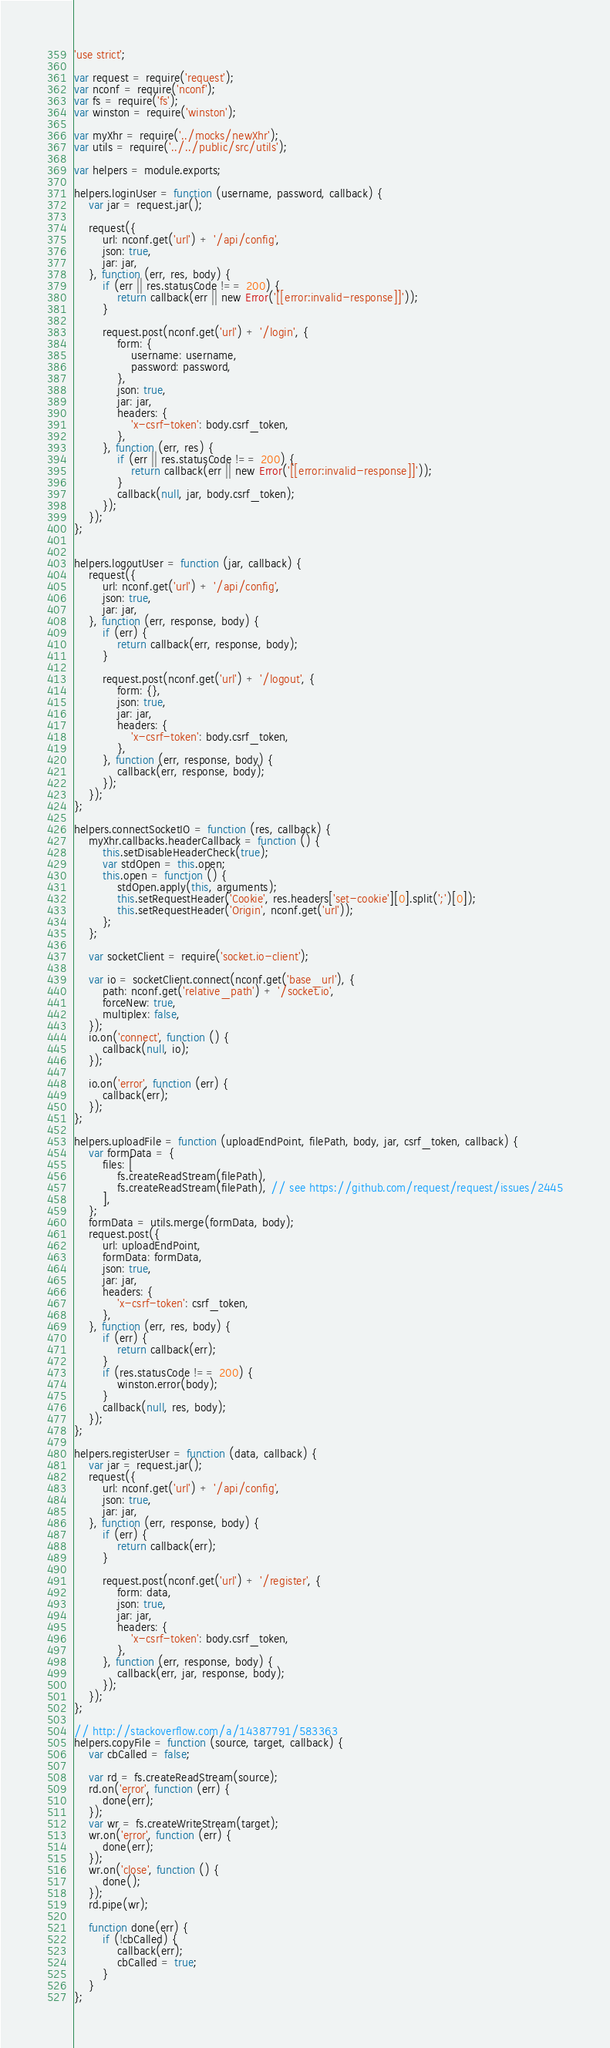<code> <loc_0><loc_0><loc_500><loc_500><_JavaScript_>'use strict';

var request = require('request');
var nconf = require('nconf');
var fs = require('fs');
var winston = require('winston');

var myXhr = require('../mocks/newXhr');
var utils = require('../../public/src/utils');

var helpers = module.exports;

helpers.loginUser = function (username, password, callback) {
	var jar = request.jar();

	request({
		url: nconf.get('url') + '/api/config',
		json: true,
		jar: jar,
	}, function (err, res, body) {
		if (err || res.statusCode !== 200) {
			return callback(err || new Error('[[error:invalid-response]]'));
		}

		request.post(nconf.get('url') + '/login', {
			form: {
				username: username,
				password: password,
			},
			json: true,
			jar: jar,
			headers: {
				'x-csrf-token': body.csrf_token,
			},
		}, function (err, res) {
			if (err || res.statusCode !== 200) {
				return callback(err || new Error('[[error:invalid-response]]'));
			}
			callback(null, jar, body.csrf_token);
		});
	});
};


helpers.logoutUser = function (jar, callback) {
	request({
		url: nconf.get('url') + '/api/config',
		json: true,
		jar: jar,
	}, function (err, response, body) {
		if (err) {
			return callback(err, response, body);
		}

		request.post(nconf.get('url') + '/logout', {
			form: {},
			json: true,
			jar: jar,
			headers: {
				'x-csrf-token': body.csrf_token,
			},
		}, function (err, response, body) {
			callback(err, response, body);
		});
	});
};

helpers.connectSocketIO = function (res, callback) {
	myXhr.callbacks.headerCallback = function () {
		this.setDisableHeaderCheck(true);
		var stdOpen = this.open;
		this.open = function () {
			stdOpen.apply(this, arguments);
			this.setRequestHeader('Cookie', res.headers['set-cookie'][0].split(';')[0]);
			this.setRequestHeader('Origin', nconf.get('url'));
		};
	};

	var socketClient = require('socket.io-client');

	var io = socketClient.connect(nconf.get('base_url'), {
		path: nconf.get('relative_path') + '/socket.io',
		forceNew: true,
		multiplex: false,
	});
	io.on('connect', function () {
		callback(null, io);
	});

	io.on('error', function (err) {
		callback(err);
	});
};

helpers.uploadFile = function (uploadEndPoint, filePath, body, jar, csrf_token, callback) {
	var formData = {
		files: [
			fs.createReadStream(filePath),
			fs.createReadStream(filePath), // see https://github.com/request/request/issues/2445
		],
	};
	formData = utils.merge(formData, body);
	request.post({
		url: uploadEndPoint,
		formData: formData,
		json: true,
		jar: jar,
		headers: {
			'x-csrf-token': csrf_token,
		},
	}, function (err, res, body) {
		if (err) {
			return callback(err);
		}
		if (res.statusCode !== 200) {
			winston.error(body);
		}
		callback(null, res, body);
	});
};

helpers.registerUser = function (data, callback) {
	var jar = request.jar();
	request({
		url: nconf.get('url') + '/api/config',
		json: true,
		jar: jar,
	}, function (err, response, body) {
		if (err) {
			return callback(err);
		}

		request.post(nconf.get('url') + '/register', {
			form: data,
			json: true,
			jar: jar,
			headers: {
				'x-csrf-token': body.csrf_token,
			},
		}, function (err, response, body) {
			callback(err, jar, response, body);
		});
	});
};

// http://stackoverflow.com/a/14387791/583363
helpers.copyFile = function (source, target, callback) {
	var cbCalled = false;

	var rd = fs.createReadStream(source);
	rd.on('error', function (err) {
		done(err);
	});
	var wr = fs.createWriteStream(target);
	wr.on('error', function (err) {
		done(err);
	});
	wr.on('close', function () {
		done();
	});
	rd.pipe(wr);

	function done(err) {
		if (!cbCalled) {
			callback(err);
			cbCalled = true;
		}
	}
};
</code> 